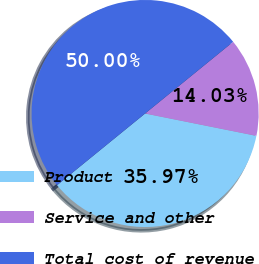Convert chart to OTSL. <chart><loc_0><loc_0><loc_500><loc_500><pie_chart><fcel>Product<fcel>Service and other<fcel>Total cost of revenue<nl><fcel>35.97%<fcel>14.03%<fcel>50.0%<nl></chart> 